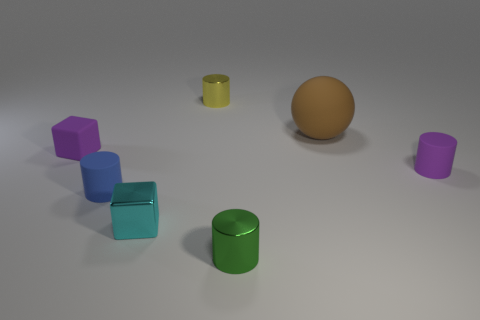Subtract all tiny purple rubber cylinders. How many cylinders are left? 3 Add 2 blue matte cylinders. How many objects exist? 9 Subtract all yellow cylinders. How many cylinders are left? 3 Subtract 2 cylinders. How many cylinders are left? 2 Subtract all balls. How many objects are left? 6 Subtract all yellow cylinders. Subtract all green balls. How many cylinders are left? 3 Subtract all big brown objects. Subtract all large brown balls. How many objects are left? 5 Add 7 small purple matte blocks. How many small purple matte blocks are left? 8 Add 4 tiny yellow shiny things. How many tiny yellow shiny things exist? 5 Subtract 0 cyan cylinders. How many objects are left? 7 